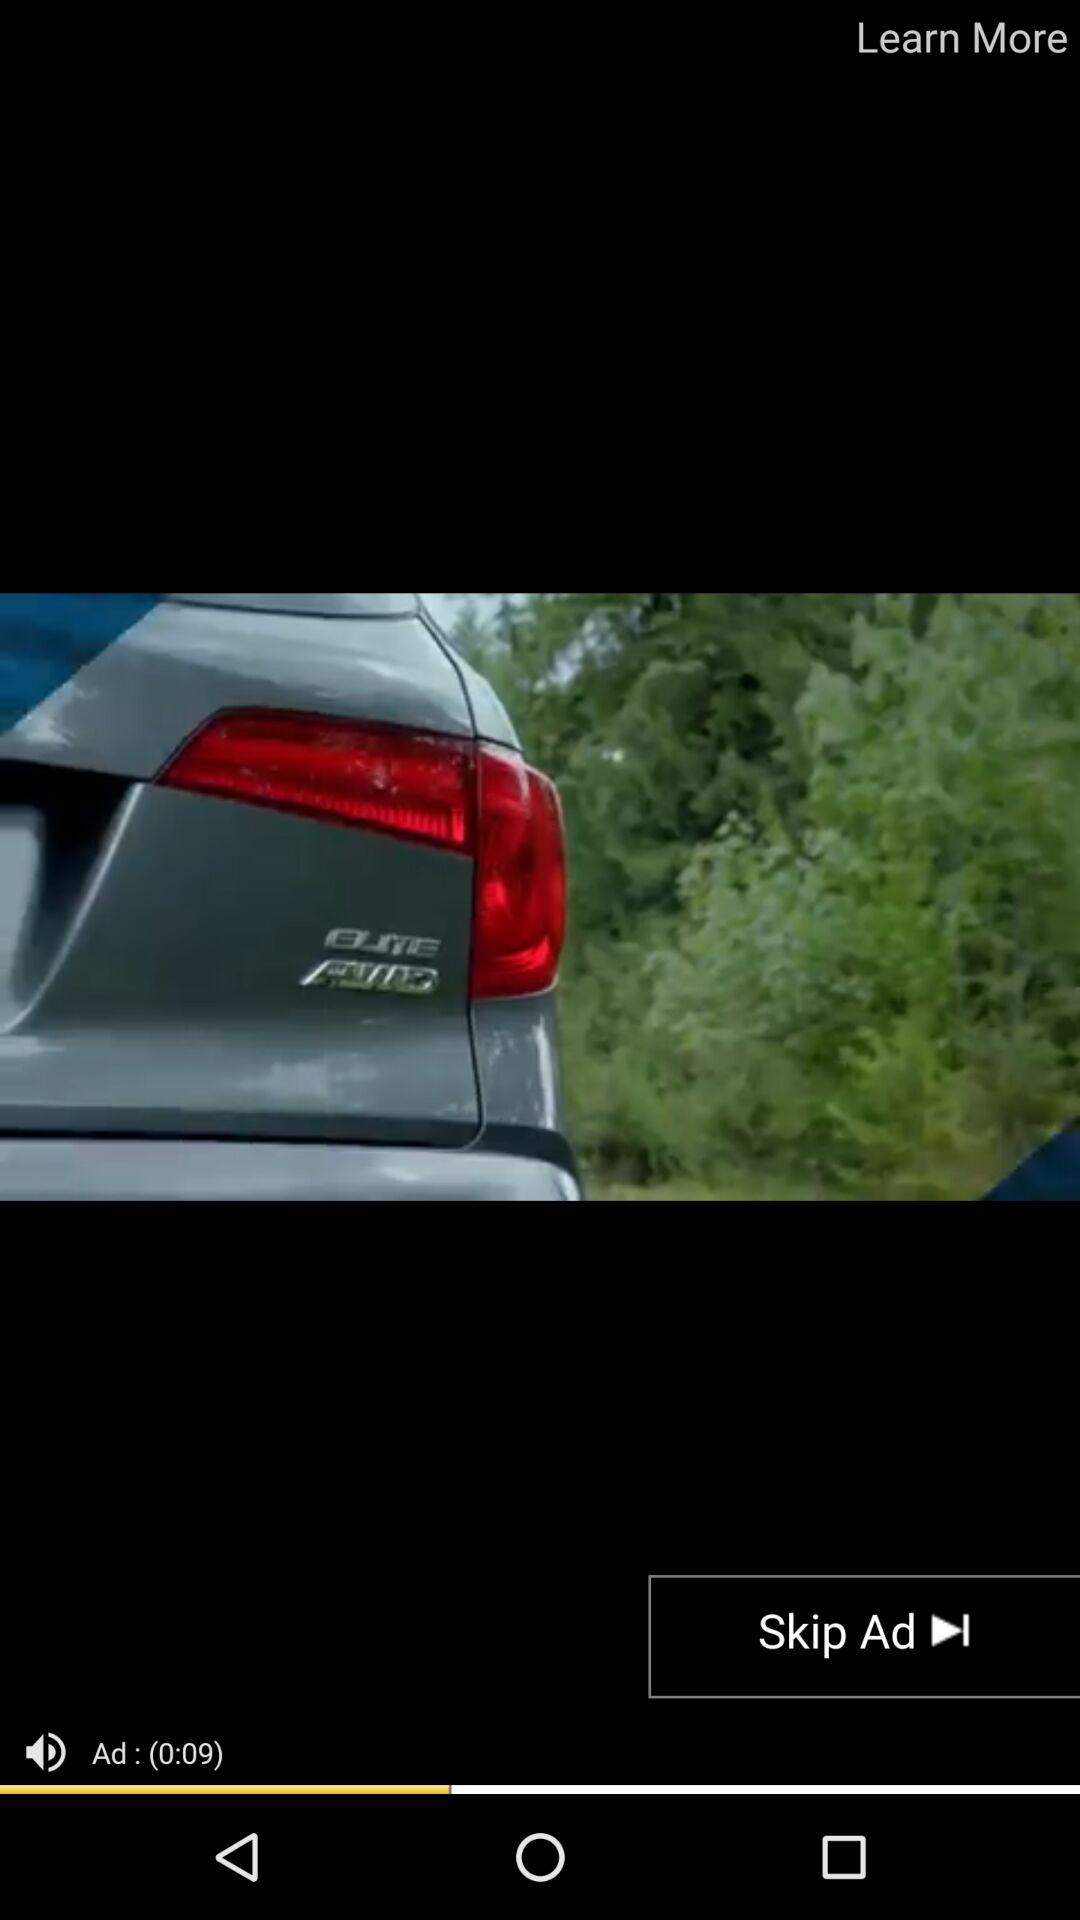How many seconds long is the ad?
Answer the question using a single word or phrase. 9 